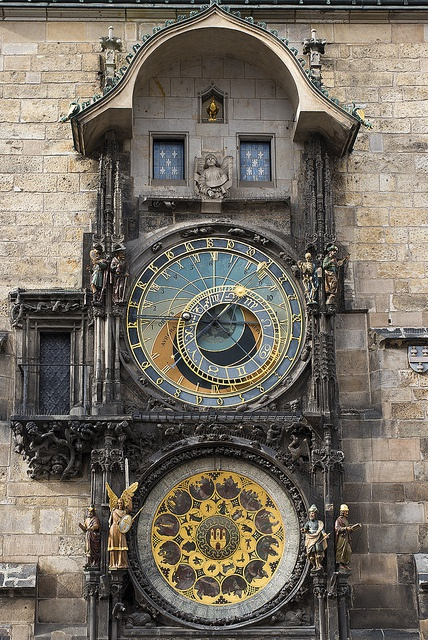Describe the objects in this image and their specific colors. I can see clock in lightblue, gray, black, and darkgray tones, clock in lightblue, gray, black, darkgray, and tan tones, people in lightblue, black, and gray tones, people in lightblue, black, gray, darkgray, and ivory tones, and people in lightblue, black, gray, and darkgray tones in this image. 